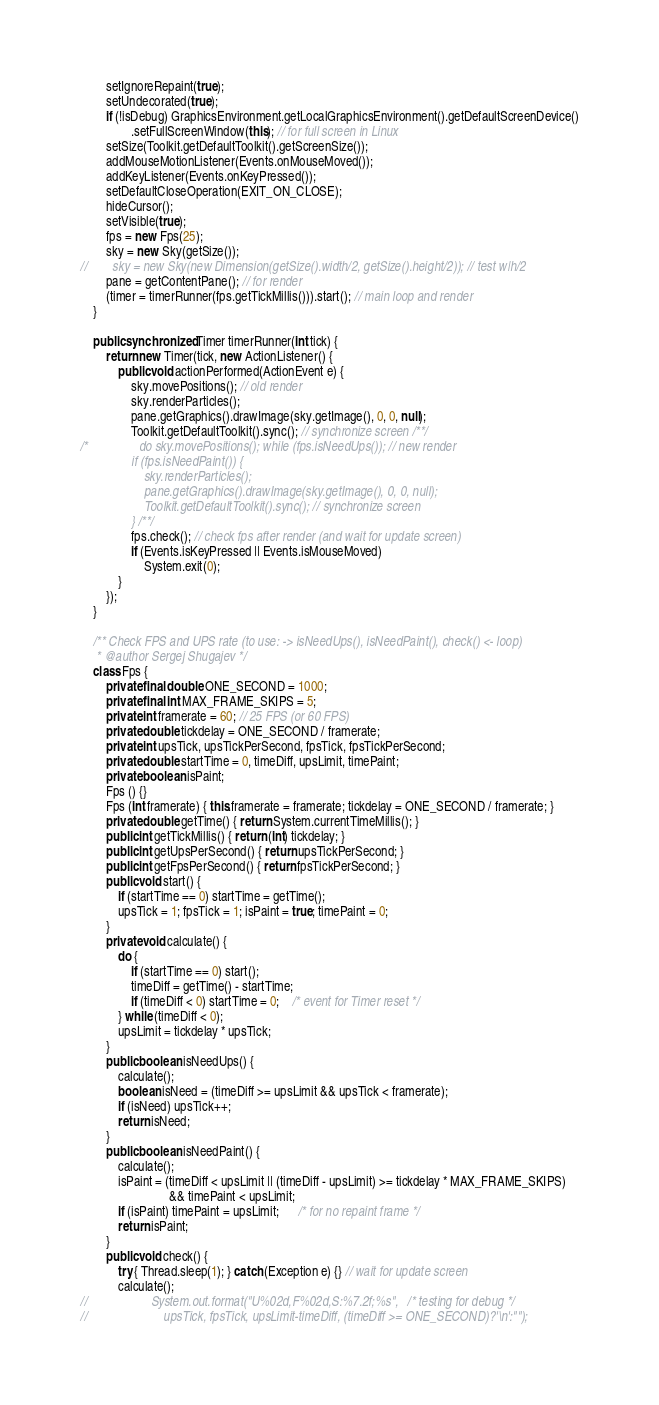<code> <loc_0><loc_0><loc_500><loc_500><_Java_>        setIgnoreRepaint(true);
        setUndecorated(true);
        if (!isDebug) GraphicsEnvironment.getLocalGraphicsEnvironment().getDefaultScreenDevice()
                .setFullScreenWindow(this); // for full screen in Linux
        setSize(Toolkit.getDefaultToolkit().getScreenSize());
        addMouseMotionListener(Events.onMouseMoved());
        addKeyListener(Events.onKeyPressed());
        setDefaultCloseOperation(EXIT_ON_CLOSE);
        hideCursor();
        setVisible(true);
        fps = new Fps(25);
        sky = new Sky(getSize());
//        sky = new Sky(new Dimension(getSize().width/2, getSize().height/2)); // test w|h/2
        pane = getContentPane(); // for render
        (timer = timerRunner(fps.getTickMillis())).start(); // main loop and render
    }
    
    public synchronized Timer timerRunner(int tick) {
        return new Timer(tick, new ActionListener() {
            public void actionPerformed(ActionEvent e) {
                sky.movePositions(); // old render
                sky.renderParticles();
                pane.getGraphics().drawImage(sky.getImage(), 0, 0, null);
                Toolkit.getDefaultToolkit().sync(); // synchronize screen /**/
/*                do sky.movePositions(); while (fps.isNeedUps()); // new render
                if (fps.isNeedPaint()) {
                    sky.renderParticles();
                    pane.getGraphics().drawImage(sky.getImage(), 0, 0, null);
                    Toolkit.getDefaultToolkit().sync(); // synchronize screen
                } /**/
                fps.check(); // check fps after render (and wait for update screen) 
                if (Events.isKeyPressed || Events.isMouseMoved)
                    System.exit(0);
            }
        });
    }
    
    /** Check FPS and UPS rate (to use: -> isNeedUps(), isNeedPaint(), check() <- loop)
     * @author Sergej Shugajev */
    class Fps {
        private final double ONE_SECOND = 1000;
        private final int MAX_FRAME_SKIPS = 5;
        private int framerate = 60; // 25 FPS (or 60 FPS)
        private double tickdelay = ONE_SECOND / framerate;
        private int upsTick, upsTickPerSecond, fpsTick, fpsTickPerSecond;
        private double startTime = 0, timeDiff, upsLimit, timePaint;
        private boolean isPaint;
        Fps () {}
        Fps (int framerate) { this.framerate = framerate; tickdelay = ONE_SECOND / framerate; }
        private double getTime() { return System.currentTimeMillis(); }
        public int getTickMillis() { return (int) tickdelay; }
        public int getUpsPerSecond() { return upsTickPerSecond; }
        public int getFpsPerSecond() { return fpsTickPerSecond; }
        public void start() {
            if (startTime == 0) startTime = getTime();
            upsTick = 1; fpsTick = 1; isPaint = true; timePaint = 0;
        }
        private void calculate() {
            do {
                if (startTime == 0) start();
                timeDiff = getTime() - startTime;
                if (timeDiff < 0) startTime = 0;    /* event for Timer reset */
            } while (timeDiff < 0);
            upsLimit = tickdelay * upsTick;
        }
        public boolean isNeedUps() {
            calculate();
            boolean isNeed = (timeDiff >= upsLimit && upsTick < framerate);
            if (isNeed) upsTick++;
            return isNeed;
        }
        public boolean isNeedPaint() {
            calculate();
            isPaint = (timeDiff < upsLimit || (timeDiff - upsLimit) >= tickdelay * MAX_FRAME_SKIPS)
                            && timePaint < upsLimit;
            if (isPaint) timePaint = upsLimit;      /* for no repaint frame */
            return isPaint;
        }
        public void check() {
            try { Thread.sleep(1); } catch (Exception e) {} // wait for update screen
            calculate();
//                    System.out.format("U%02d,F%02d,S:%7.2f;%s",   /* testing for debug */
//                        upsTick, fpsTick, upsLimit-timeDiff, (timeDiff >= ONE_SECOND)?'\n':"");</code> 